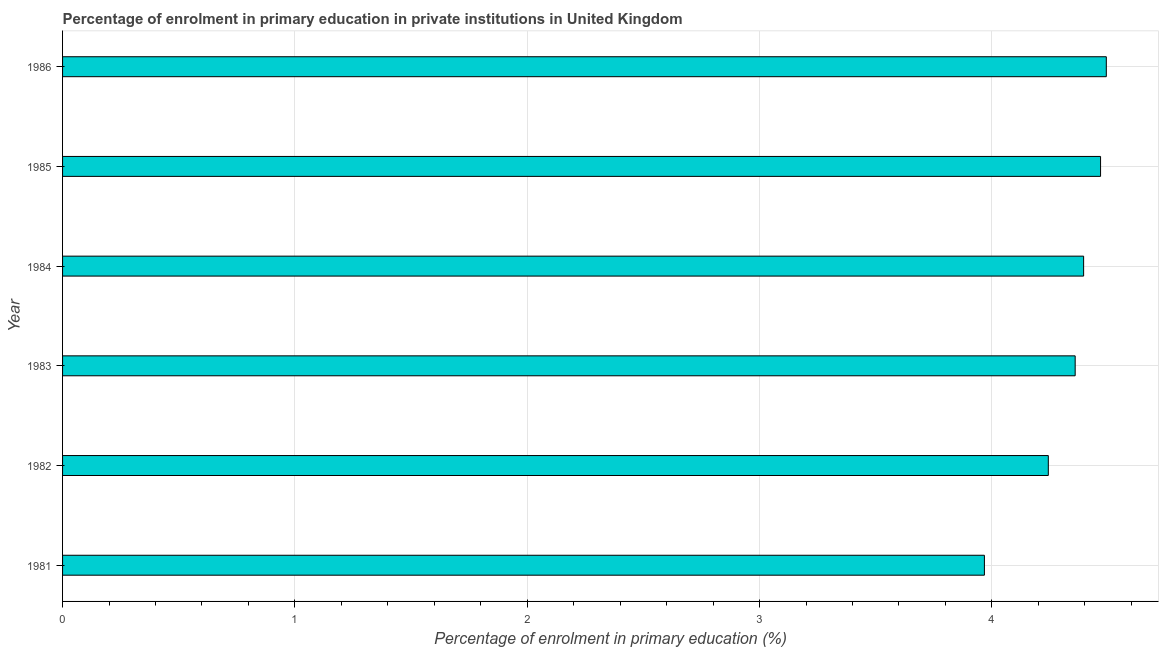Does the graph contain any zero values?
Keep it short and to the point. No. Does the graph contain grids?
Your answer should be compact. Yes. What is the title of the graph?
Your answer should be very brief. Percentage of enrolment in primary education in private institutions in United Kingdom. What is the label or title of the X-axis?
Provide a short and direct response. Percentage of enrolment in primary education (%). What is the enrolment percentage in primary education in 1983?
Offer a terse response. 4.36. Across all years, what is the maximum enrolment percentage in primary education?
Make the answer very short. 4.49. Across all years, what is the minimum enrolment percentage in primary education?
Your answer should be very brief. 3.97. In which year was the enrolment percentage in primary education maximum?
Give a very brief answer. 1986. In which year was the enrolment percentage in primary education minimum?
Ensure brevity in your answer.  1981. What is the sum of the enrolment percentage in primary education?
Provide a succinct answer. 25.92. What is the difference between the enrolment percentage in primary education in 1983 and 1986?
Provide a short and direct response. -0.13. What is the average enrolment percentage in primary education per year?
Your answer should be compact. 4.32. What is the median enrolment percentage in primary education?
Your response must be concise. 4.38. In how many years, is the enrolment percentage in primary education greater than 3 %?
Ensure brevity in your answer.  6. Is the enrolment percentage in primary education in 1982 less than that in 1986?
Ensure brevity in your answer.  Yes. Is the difference between the enrolment percentage in primary education in 1982 and 1985 greater than the difference between any two years?
Make the answer very short. No. What is the difference between the highest and the second highest enrolment percentage in primary education?
Provide a succinct answer. 0.03. What is the difference between the highest and the lowest enrolment percentage in primary education?
Keep it short and to the point. 0.52. In how many years, is the enrolment percentage in primary education greater than the average enrolment percentage in primary education taken over all years?
Offer a very short reply. 4. What is the difference between two consecutive major ticks on the X-axis?
Provide a short and direct response. 1. What is the Percentage of enrolment in primary education (%) in 1981?
Provide a succinct answer. 3.97. What is the Percentage of enrolment in primary education (%) of 1982?
Your answer should be compact. 4.24. What is the Percentage of enrolment in primary education (%) of 1983?
Ensure brevity in your answer.  4.36. What is the Percentage of enrolment in primary education (%) of 1984?
Offer a very short reply. 4.39. What is the Percentage of enrolment in primary education (%) of 1985?
Give a very brief answer. 4.47. What is the Percentage of enrolment in primary education (%) in 1986?
Your response must be concise. 4.49. What is the difference between the Percentage of enrolment in primary education (%) in 1981 and 1982?
Your response must be concise. -0.28. What is the difference between the Percentage of enrolment in primary education (%) in 1981 and 1983?
Give a very brief answer. -0.39. What is the difference between the Percentage of enrolment in primary education (%) in 1981 and 1984?
Make the answer very short. -0.43. What is the difference between the Percentage of enrolment in primary education (%) in 1981 and 1985?
Provide a succinct answer. -0.5. What is the difference between the Percentage of enrolment in primary education (%) in 1981 and 1986?
Provide a short and direct response. -0.52. What is the difference between the Percentage of enrolment in primary education (%) in 1982 and 1983?
Your response must be concise. -0.12. What is the difference between the Percentage of enrolment in primary education (%) in 1982 and 1984?
Provide a short and direct response. -0.15. What is the difference between the Percentage of enrolment in primary education (%) in 1982 and 1985?
Ensure brevity in your answer.  -0.22. What is the difference between the Percentage of enrolment in primary education (%) in 1982 and 1986?
Your answer should be very brief. -0.25. What is the difference between the Percentage of enrolment in primary education (%) in 1983 and 1984?
Make the answer very short. -0.04. What is the difference between the Percentage of enrolment in primary education (%) in 1983 and 1985?
Your response must be concise. -0.11. What is the difference between the Percentage of enrolment in primary education (%) in 1983 and 1986?
Ensure brevity in your answer.  -0.13. What is the difference between the Percentage of enrolment in primary education (%) in 1984 and 1985?
Provide a short and direct response. -0.07. What is the difference between the Percentage of enrolment in primary education (%) in 1984 and 1986?
Your answer should be very brief. -0.1. What is the difference between the Percentage of enrolment in primary education (%) in 1985 and 1986?
Keep it short and to the point. -0.02. What is the ratio of the Percentage of enrolment in primary education (%) in 1981 to that in 1982?
Offer a very short reply. 0.94. What is the ratio of the Percentage of enrolment in primary education (%) in 1981 to that in 1983?
Offer a terse response. 0.91. What is the ratio of the Percentage of enrolment in primary education (%) in 1981 to that in 1984?
Provide a succinct answer. 0.9. What is the ratio of the Percentage of enrolment in primary education (%) in 1981 to that in 1985?
Give a very brief answer. 0.89. What is the ratio of the Percentage of enrolment in primary education (%) in 1981 to that in 1986?
Your answer should be compact. 0.88. What is the ratio of the Percentage of enrolment in primary education (%) in 1982 to that in 1983?
Offer a terse response. 0.97. What is the ratio of the Percentage of enrolment in primary education (%) in 1982 to that in 1984?
Your answer should be very brief. 0.96. What is the ratio of the Percentage of enrolment in primary education (%) in 1982 to that in 1986?
Your response must be concise. 0.94. What is the ratio of the Percentage of enrolment in primary education (%) in 1983 to that in 1984?
Ensure brevity in your answer.  0.99. What is the ratio of the Percentage of enrolment in primary education (%) in 1983 to that in 1986?
Provide a succinct answer. 0.97. 